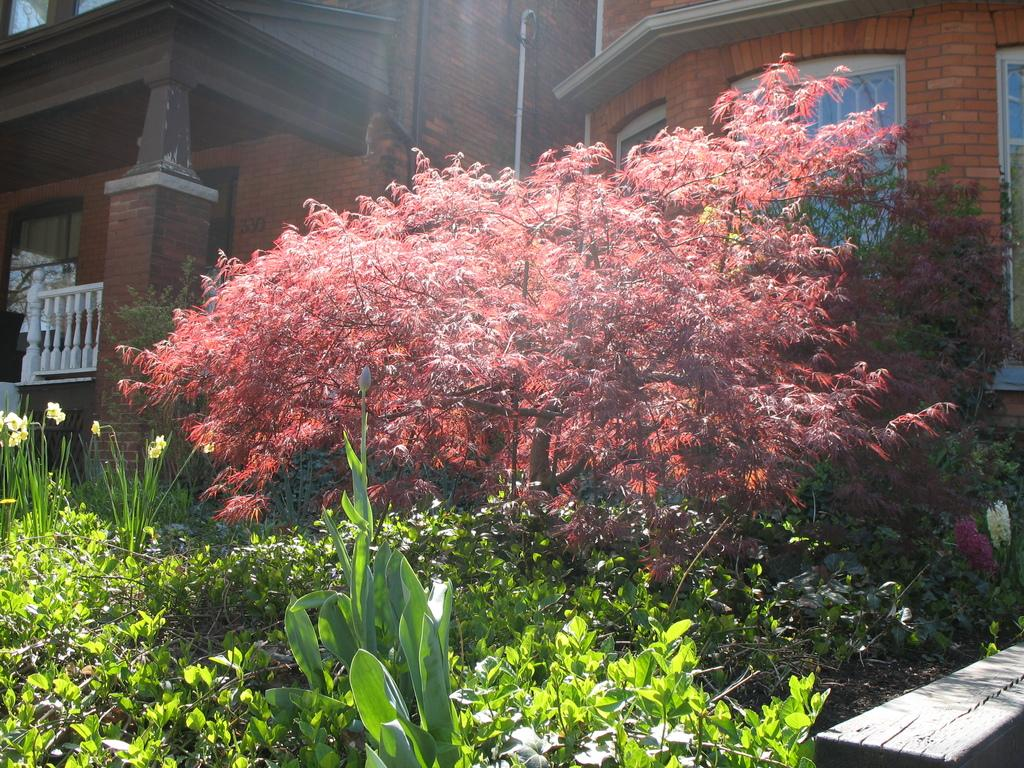What is located at the bottom of the image? There are plants at the bottom of the image. What can be seen in the background of the image? There are buildings with windows in the background of the image. What type of stage is visible in the image? There is no stage present in the image. How many screws can be seen holding the vase together in the image? There is no vase present in the image, and therefore no screws can be observed. 